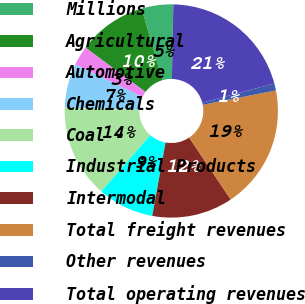Convert chart to OTSL. <chart><loc_0><loc_0><loc_500><loc_500><pie_chart><fcel>Millions<fcel>Agricultural<fcel>Automotive<fcel>Chemicals<fcel>Coal<fcel>Industrial Products<fcel>Intermodal<fcel>Total freight revenues<fcel>Other revenues<fcel>Total operating revenues<nl><fcel>4.79%<fcel>10.4%<fcel>2.93%<fcel>6.66%<fcel>14.13%<fcel>8.53%<fcel>12.27%<fcel>18.68%<fcel>1.06%<fcel>20.55%<nl></chart> 